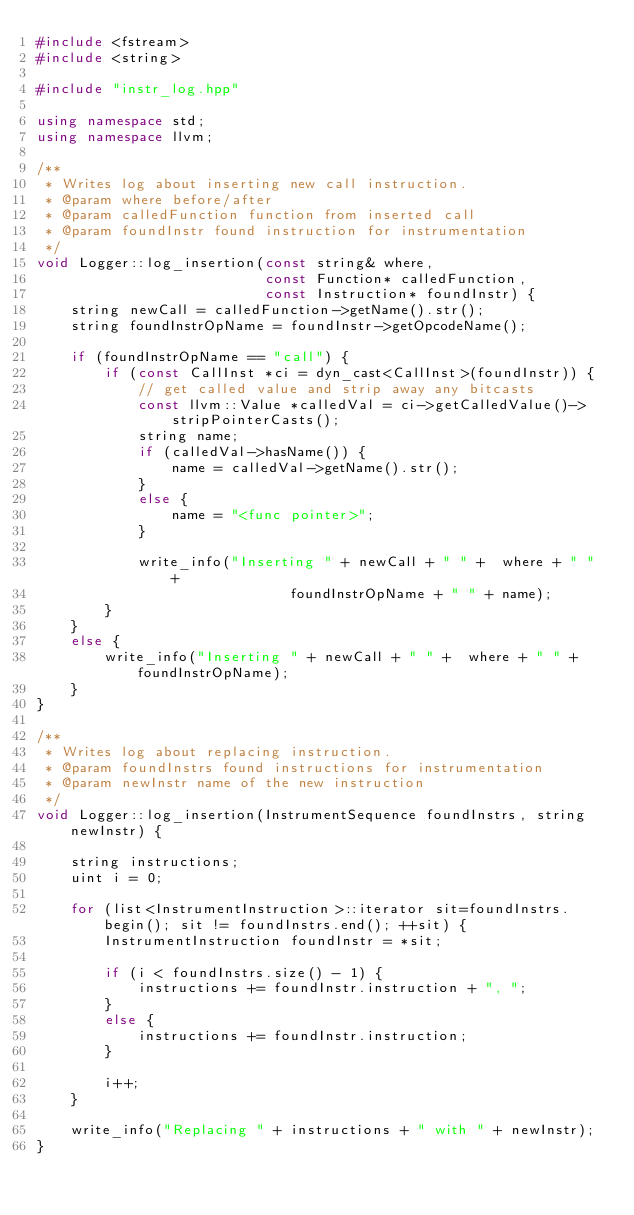<code> <loc_0><loc_0><loc_500><loc_500><_C++_>#include <fstream>
#include <string>

#include "instr_log.hpp"

using namespace std;
using namespace llvm;

/**
 * Writes log about inserting new call instruction.
 * @param where before/after
 * @param calledFunction function from inserted call
 * @param foundInstr found instruction for instrumentation
 */
void Logger::log_insertion(const string& where,
                           const Function* calledFunction,
                           const Instruction* foundInstr) {
    string newCall = calledFunction->getName().str();
    string foundInstrOpName = foundInstr->getOpcodeName();

    if (foundInstrOpName == "call") {
        if (const CallInst *ci = dyn_cast<CallInst>(foundInstr)) {
            // get called value and strip away any bitcasts
            const llvm::Value *calledVal = ci->getCalledValue()->stripPointerCasts();
            string name;
            if (calledVal->hasName()) {
                name = calledVal->getName().str();
            }
            else {
                name = "<func pointer>";
            }

            write_info("Inserting " + newCall + " " +  where + " " +
                              foundInstrOpName + " " + name);
        }
    }
    else {
        write_info("Inserting " + newCall + " " +  where + " " + foundInstrOpName);
    }
}

/**
 * Writes log about replacing instruction.
 * @param foundInstrs found instructions for instrumentation
 * @param newInstr name of the new instruction
 */
void Logger::log_insertion(InstrumentSequence foundInstrs, string newInstr) {

    string instructions;
    uint i = 0;

    for (list<InstrumentInstruction>::iterator sit=foundInstrs.begin(); sit != foundInstrs.end(); ++sit) {
        InstrumentInstruction foundInstr = *sit;

        if (i < foundInstrs.size() - 1) {
            instructions += foundInstr.instruction + ", ";
        }
        else {
            instructions += foundInstr.instruction;
        }

        i++;
    }

    write_info("Replacing " + instructions + " with " + newInstr);
}
</code> 